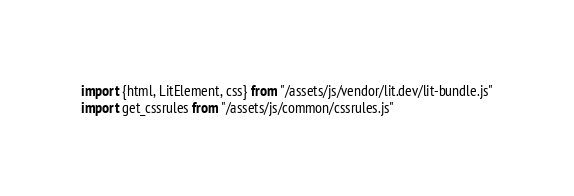Convert code to text. <code><loc_0><loc_0><loc_500><loc_500><_JavaScript_>import {html, LitElement, css} from "/assets/js/vendor/lit.dev/lit-bundle.js"
import get_cssrules from "/assets/js/common/cssrules.js"</code> 